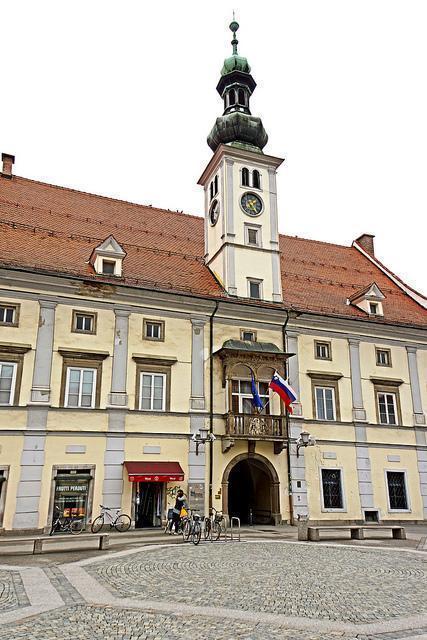What is under the clock tower?
Indicate the correct response by choosing from the four available options to answer the question.
Options: Sports cars, cats, flags, turkeys. Flags. What can you use the bike rack for to keep your bike safe?
Choose the correct response, then elucidate: 'Answer: answer
Rationale: rationale.'
Options: Selling bike, cleaning bike, leaning bike, bike lock. Answer: bike lock.
Rationale: A bike lock is a lock that is put on a bike that keep it secure so someone can't steal off the rack. 